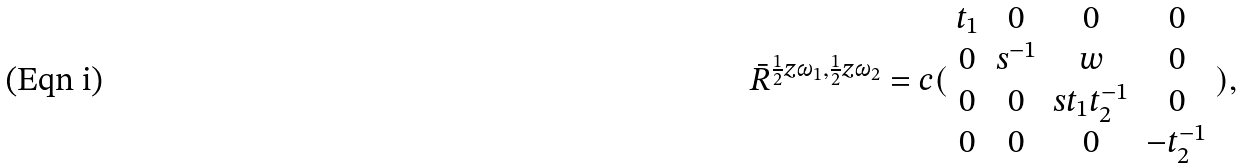<formula> <loc_0><loc_0><loc_500><loc_500>\bar { R } ^ { \frac { 1 } { 2 } z \omega _ { 1 } , \frac { 1 } { 2 } z \omega _ { 2 } } = c ( \begin{array} { c c c c } t _ { 1 } & 0 & 0 & 0 \\ 0 & s ^ { - 1 } & w & 0 \\ 0 & 0 & s t _ { 1 } t _ { 2 } ^ { - 1 } & 0 \\ 0 & 0 & 0 & - t _ { 2 } ^ { - 1 } \end{array} ) ,</formula> 